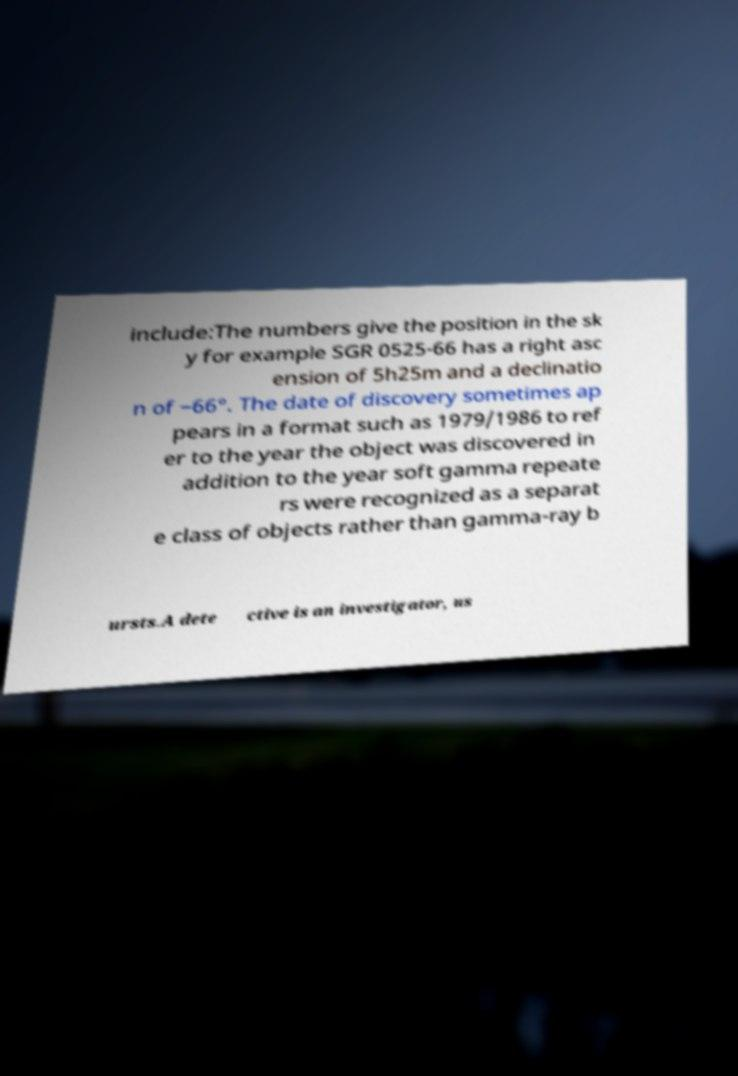I need the written content from this picture converted into text. Can you do that? include:The numbers give the position in the sk y for example SGR 0525-66 has a right asc ension of 5h25m and a declinatio n of −66°. The date of discovery sometimes ap pears in a format such as 1979/1986 to ref er to the year the object was discovered in addition to the year soft gamma repeate rs were recognized as a separat e class of objects rather than gamma-ray b ursts.A dete ctive is an investigator, us 